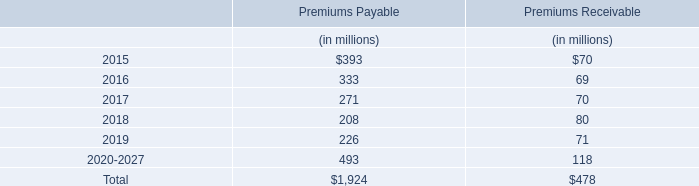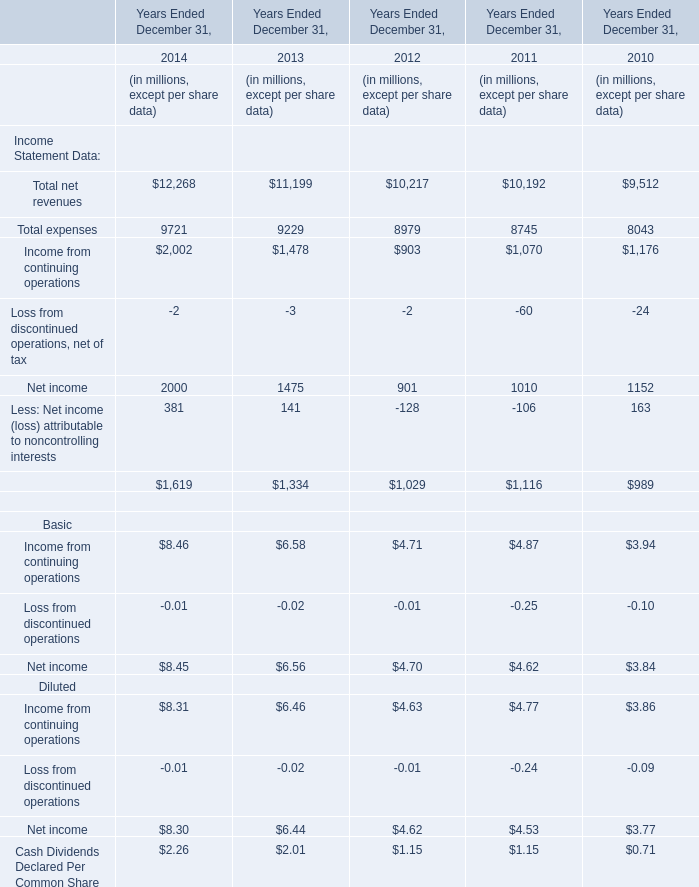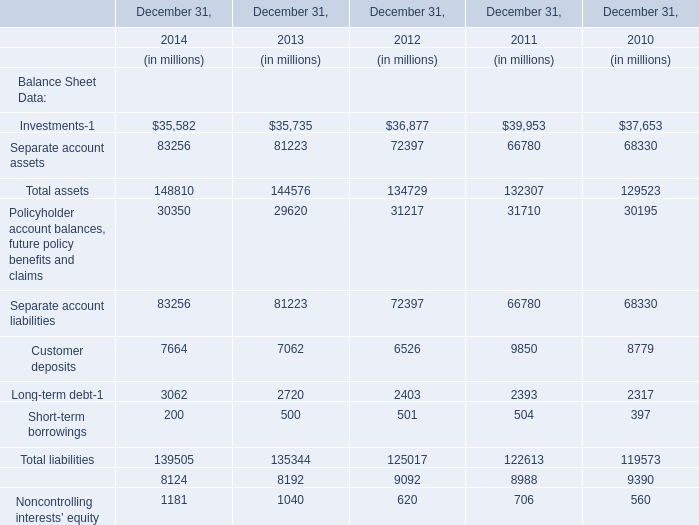What was the total amount of the Separate account assets in the years where Investments is greater than 36877? (in million) 
Computations: ((72397 + 66780) + 68330)
Answer: 207507.0. 